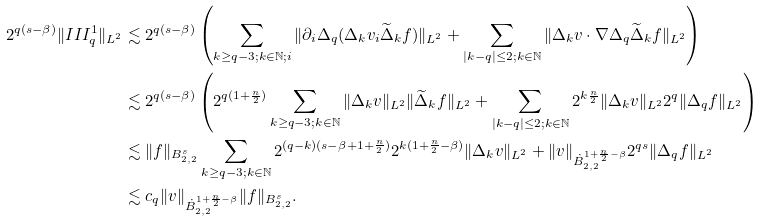Convert formula to latex. <formula><loc_0><loc_0><loc_500><loc_500>2 ^ { q ( s - \beta ) } \| I I I ^ { 1 } _ { q } \| _ { L ^ { 2 } } & \lesssim 2 ^ { q ( s - \beta ) } \left ( \sum _ { k \geq q - 3 ; k \in \mathbb { N } ; i } \| \partial _ { i } \Delta _ { q } ( \Delta _ { k } v _ { i } \widetilde { \Delta } _ { k } f ) \| _ { L ^ { 2 } } + \sum _ { | k - q | \leq 2 ; k \in \mathbb { N } } \| \Delta _ { k } v \cdot \nabla \Delta _ { q } \widetilde { \Delta } _ { k } f \| _ { L ^ { 2 } } \right ) \\ & \lesssim 2 ^ { q ( s - \beta ) } \left ( 2 ^ { q ( 1 + \frac { n } { 2 } ) } \sum _ { k \geq q - 3 ; k \in \mathbb { N } } \| \Delta _ { k } v \| _ { L ^ { 2 } } \| \widetilde { \Delta } _ { k } f \| _ { L ^ { 2 } } + \sum _ { | k - q | \leq 2 ; k \in \mathbb { N } } 2 ^ { k \frac { n } { 2 } } \| \Delta _ { k } v \| _ { L ^ { 2 } } 2 ^ { q } \| \Delta _ { q } f \| _ { L ^ { 2 } } \right ) \\ & \lesssim \| f \| _ { B _ { 2 , 2 } ^ { s } } \sum _ { k \geq q - 3 ; k \in \mathbb { N } } 2 ^ { ( q - k ) ( s - \beta + 1 + \frac { n } { 2 } ) } 2 ^ { k ( 1 + \frac { n } { 2 } - \beta ) } \| \Delta _ { k } v \| _ { L ^ { 2 } } + \| v \| _ { \dot { B } _ { 2 , 2 } ^ { 1 + \frac { n } { 2 } - \beta } } 2 ^ { q s } \| \Delta _ { q } f \| _ { L ^ { 2 } } \\ & \lesssim c _ { q } \| v \| _ { \dot { B } _ { 2 , 2 } ^ { 1 + \frac { n } { 2 } - \beta } } \| f \| _ { B _ { 2 , 2 } ^ { s } } .</formula> 